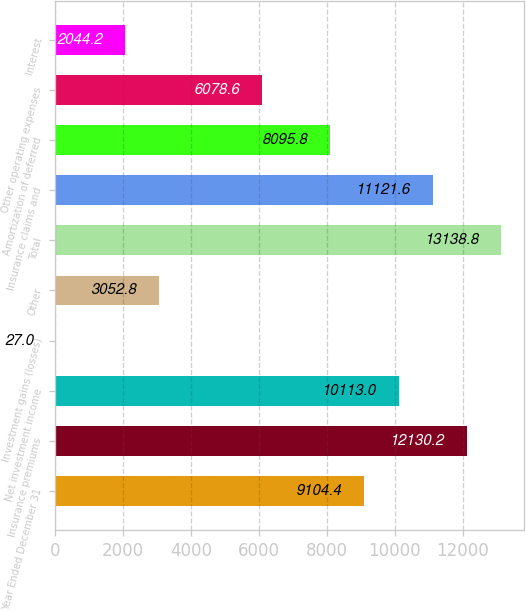<chart> <loc_0><loc_0><loc_500><loc_500><bar_chart><fcel>Year Ended December 31<fcel>Insurance premiums<fcel>Net investment income<fcel>Investment gains (losses)<fcel>Other<fcel>Total<fcel>Insurance claims and<fcel>Amortization of deferred<fcel>Other operating expenses<fcel>Interest<nl><fcel>9104.4<fcel>12130.2<fcel>10113<fcel>27<fcel>3052.8<fcel>13138.8<fcel>11121.6<fcel>8095.8<fcel>6078.6<fcel>2044.2<nl></chart> 